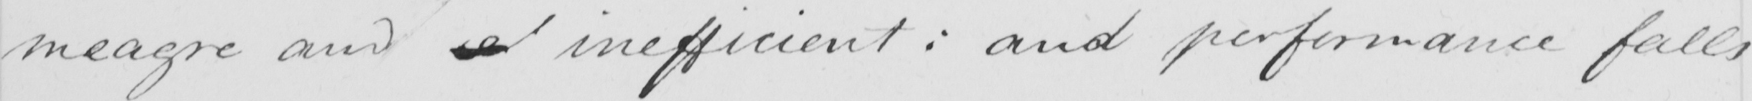What is written in this line of handwriting? meagre and  <gap/>  inefficient :  and performance falls 